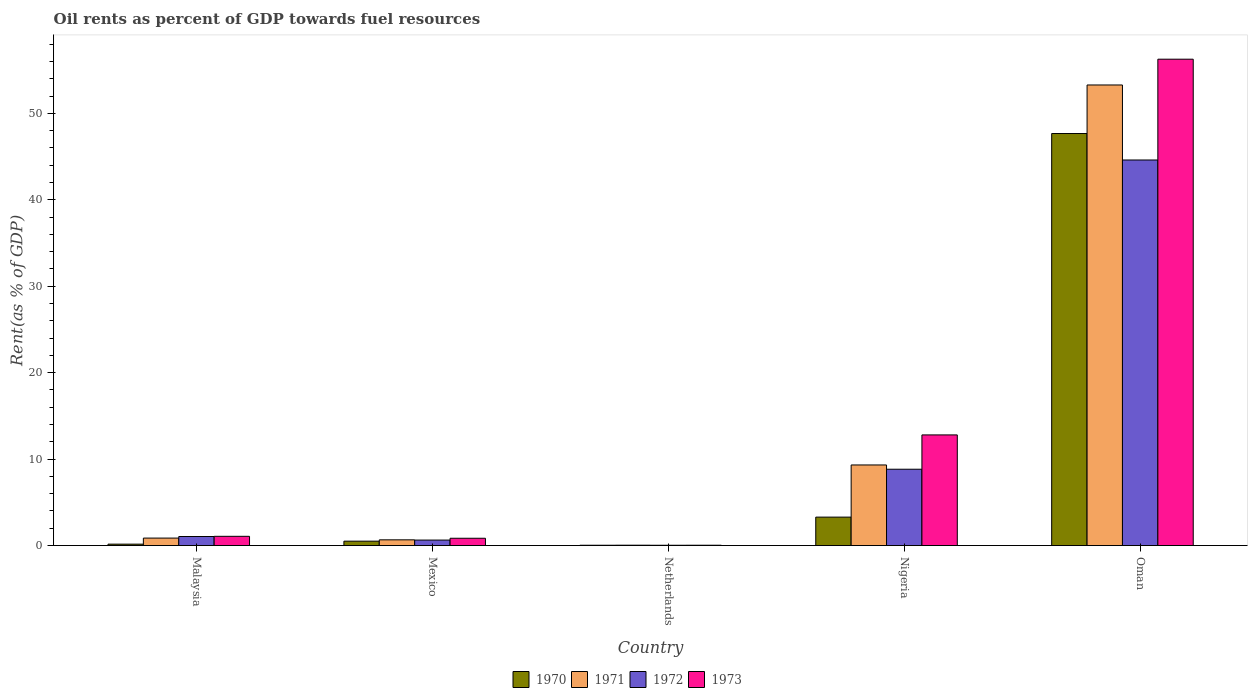Are the number of bars on each tick of the X-axis equal?
Your answer should be very brief. Yes. In how many cases, is the number of bars for a given country not equal to the number of legend labels?
Ensure brevity in your answer.  0. What is the oil rent in 1972 in Oman?
Offer a terse response. 44.6. Across all countries, what is the maximum oil rent in 1972?
Provide a short and direct response. 44.6. Across all countries, what is the minimum oil rent in 1973?
Your answer should be very brief. 0.04. In which country was the oil rent in 1970 maximum?
Offer a terse response. Oman. What is the total oil rent in 1970 in the graph?
Your response must be concise. 51.66. What is the difference between the oil rent in 1970 in Mexico and that in Nigeria?
Offer a terse response. -2.78. What is the difference between the oil rent in 1973 in Nigeria and the oil rent in 1972 in Oman?
Your answer should be compact. -31.8. What is the average oil rent in 1973 per country?
Offer a very short reply. 14.2. What is the difference between the oil rent of/in 1971 and oil rent of/in 1973 in Malaysia?
Provide a short and direct response. -0.2. What is the ratio of the oil rent in 1970 in Mexico to that in Nigeria?
Give a very brief answer. 0.15. Is the difference between the oil rent in 1971 in Mexico and Nigeria greater than the difference between the oil rent in 1973 in Mexico and Nigeria?
Your answer should be compact. Yes. What is the difference between the highest and the second highest oil rent in 1970?
Your answer should be very brief. -2.78. What is the difference between the highest and the lowest oil rent in 1970?
Provide a short and direct response. 47.62. In how many countries, is the oil rent in 1970 greater than the average oil rent in 1970 taken over all countries?
Ensure brevity in your answer.  1. Is it the case that in every country, the sum of the oil rent in 1970 and oil rent in 1972 is greater than the sum of oil rent in 1973 and oil rent in 1971?
Make the answer very short. No. Is it the case that in every country, the sum of the oil rent in 1970 and oil rent in 1972 is greater than the oil rent in 1971?
Make the answer very short. Yes. Are all the bars in the graph horizontal?
Your answer should be compact. No. Are the values on the major ticks of Y-axis written in scientific E-notation?
Make the answer very short. No. Does the graph contain grids?
Your answer should be compact. No. Where does the legend appear in the graph?
Provide a succinct answer. Bottom center. How are the legend labels stacked?
Provide a succinct answer. Horizontal. What is the title of the graph?
Give a very brief answer. Oil rents as percent of GDP towards fuel resources. Does "1966" appear as one of the legend labels in the graph?
Ensure brevity in your answer.  No. What is the label or title of the X-axis?
Give a very brief answer. Country. What is the label or title of the Y-axis?
Provide a succinct answer. Rent(as % of GDP). What is the Rent(as % of GDP) in 1970 in Malaysia?
Give a very brief answer. 0.16. What is the Rent(as % of GDP) in 1971 in Malaysia?
Offer a terse response. 0.86. What is the Rent(as % of GDP) in 1972 in Malaysia?
Ensure brevity in your answer.  1.05. What is the Rent(as % of GDP) in 1973 in Malaysia?
Offer a terse response. 1.07. What is the Rent(as % of GDP) in 1970 in Mexico?
Keep it short and to the point. 0.51. What is the Rent(as % of GDP) of 1971 in Mexico?
Keep it short and to the point. 0.66. What is the Rent(as % of GDP) of 1972 in Mexico?
Offer a terse response. 0.63. What is the Rent(as % of GDP) of 1973 in Mexico?
Keep it short and to the point. 0.84. What is the Rent(as % of GDP) in 1970 in Netherlands?
Offer a very short reply. 0.04. What is the Rent(as % of GDP) in 1971 in Netherlands?
Your answer should be very brief. 0.04. What is the Rent(as % of GDP) in 1972 in Netherlands?
Ensure brevity in your answer.  0.03. What is the Rent(as % of GDP) of 1973 in Netherlands?
Offer a terse response. 0.04. What is the Rent(as % of GDP) in 1970 in Nigeria?
Give a very brief answer. 3.29. What is the Rent(as % of GDP) of 1971 in Nigeria?
Make the answer very short. 9.32. What is the Rent(as % of GDP) of 1972 in Nigeria?
Ensure brevity in your answer.  8.83. What is the Rent(as % of GDP) of 1973 in Nigeria?
Make the answer very short. 12.8. What is the Rent(as % of GDP) of 1970 in Oman?
Give a very brief answer. 47.66. What is the Rent(as % of GDP) in 1971 in Oman?
Ensure brevity in your answer.  53.28. What is the Rent(as % of GDP) in 1972 in Oman?
Ensure brevity in your answer.  44.6. What is the Rent(as % of GDP) of 1973 in Oman?
Your answer should be very brief. 56.26. Across all countries, what is the maximum Rent(as % of GDP) in 1970?
Offer a very short reply. 47.66. Across all countries, what is the maximum Rent(as % of GDP) of 1971?
Your response must be concise. 53.28. Across all countries, what is the maximum Rent(as % of GDP) in 1972?
Make the answer very short. 44.6. Across all countries, what is the maximum Rent(as % of GDP) in 1973?
Ensure brevity in your answer.  56.26. Across all countries, what is the minimum Rent(as % of GDP) of 1970?
Offer a very short reply. 0.04. Across all countries, what is the minimum Rent(as % of GDP) of 1971?
Ensure brevity in your answer.  0.04. Across all countries, what is the minimum Rent(as % of GDP) in 1972?
Your response must be concise. 0.03. Across all countries, what is the minimum Rent(as % of GDP) in 1973?
Make the answer very short. 0.04. What is the total Rent(as % of GDP) of 1970 in the graph?
Make the answer very short. 51.66. What is the total Rent(as % of GDP) in 1971 in the graph?
Ensure brevity in your answer.  64.17. What is the total Rent(as % of GDP) of 1972 in the graph?
Your answer should be compact. 55.15. What is the total Rent(as % of GDP) of 1973 in the graph?
Offer a terse response. 71.01. What is the difference between the Rent(as % of GDP) in 1970 in Malaysia and that in Mexico?
Provide a short and direct response. -0.35. What is the difference between the Rent(as % of GDP) of 1971 in Malaysia and that in Mexico?
Make the answer very short. 0.2. What is the difference between the Rent(as % of GDP) in 1972 in Malaysia and that in Mexico?
Offer a very short reply. 0.41. What is the difference between the Rent(as % of GDP) of 1973 in Malaysia and that in Mexico?
Provide a succinct answer. 0.22. What is the difference between the Rent(as % of GDP) of 1970 in Malaysia and that in Netherlands?
Provide a short and direct response. 0.13. What is the difference between the Rent(as % of GDP) of 1971 in Malaysia and that in Netherlands?
Make the answer very short. 0.82. What is the difference between the Rent(as % of GDP) in 1972 in Malaysia and that in Netherlands?
Make the answer very short. 1.01. What is the difference between the Rent(as % of GDP) in 1973 in Malaysia and that in Netherlands?
Provide a succinct answer. 1.03. What is the difference between the Rent(as % of GDP) of 1970 in Malaysia and that in Nigeria?
Your response must be concise. -3.13. What is the difference between the Rent(as % of GDP) of 1971 in Malaysia and that in Nigeria?
Ensure brevity in your answer.  -8.46. What is the difference between the Rent(as % of GDP) in 1972 in Malaysia and that in Nigeria?
Give a very brief answer. -7.78. What is the difference between the Rent(as % of GDP) in 1973 in Malaysia and that in Nigeria?
Make the answer very short. -11.73. What is the difference between the Rent(as % of GDP) of 1970 in Malaysia and that in Oman?
Give a very brief answer. -47.5. What is the difference between the Rent(as % of GDP) of 1971 in Malaysia and that in Oman?
Your answer should be very brief. -52.41. What is the difference between the Rent(as % of GDP) in 1972 in Malaysia and that in Oman?
Provide a succinct answer. -43.55. What is the difference between the Rent(as % of GDP) in 1973 in Malaysia and that in Oman?
Provide a succinct answer. -55.19. What is the difference between the Rent(as % of GDP) in 1970 in Mexico and that in Netherlands?
Offer a terse response. 0.47. What is the difference between the Rent(as % of GDP) in 1971 in Mexico and that in Netherlands?
Provide a succinct answer. 0.62. What is the difference between the Rent(as % of GDP) of 1973 in Mexico and that in Netherlands?
Offer a very short reply. 0.81. What is the difference between the Rent(as % of GDP) in 1970 in Mexico and that in Nigeria?
Your response must be concise. -2.78. What is the difference between the Rent(as % of GDP) of 1971 in Mexico and that in Nigeria?
Provide a succinct answer. -8.66. What is the difference between the Rent(as % of GDP) of 1972 in Mexico and that in Nigeria?
Ensure brevity in your answer.  -8.19. What is the difference between the Rent(as % of GDP) in 1973 in Mexico and that in Nigeria?
Your answer should be very brief. -11.95. What is the difference between the Rent(as % of GDP) in 1970 in Mexico and that in Oman?
Offer a very short reply. -47.15. What is the difference between the Rent(as % of GDP) of 1971 in Mexico and that in Oman?
Provide a short and direct response. -52.61. What is the difference between the Rent(as % of GDP) in 1972 in Mexico and that in Oman?
Make the answer very short. -43.97. What is the difference between the Rent(as % of GDP) in 1973 in Mexico and that in Oman?
Give a very brief answer. -55.41. What is the difference between the Rent(as % of GDP) of 1970 in Netherlands and that in Nigeria?
Offer a very short reply. -3.25. What is the difference between the Rent(as % of GDP) in 1971 in Netherlands and that in Nigeria?
Give a very brief answer. -9.28. What is the difference between the Rent(as % of GDP) in 1972 in Netherlands and that in Nigeria?
Provide a succinct answer. -8.79. What is the difference between the Rent(as % of GDP) of 1973 in Netherlands and that in Nigeria?
Offer a terse response. -12.76. What is the difference between the Rent(as % of GDP) in 1970 in Netherlands and that in Oman?
Offer a very short reply. -47.62. What is the difference between the Rent(as % of GDP) in 1971 in Netherlands and that in Oman?
Make the answer very short. -53.23. What is the difference between the Rent(as % of GDP) of 1972 in Netherlands and that in Oman?
Make the answer very short. -44.57. What is the difference between the Rent(as % of GDP) in 1973 in Netherlands and that in Oman?
Offer a very short reply. -56.22. What is the difference between the Rent(as % of GDP) in 1970 in Nigeria and that in Oman?
Keep it short and to the point. -44.37. What is the difference between the Rent(as % of GDP) in 1971 in Nigeria and that in Oman?
Give a very brief answer. -43.95. What is the difference between the Rent(as % of GDP) in 1972 in Nigeria and that in Oman?
Your answer should be compact. -35.77. What is the difference between the Rent(as % of GDP) in 1973 in Nigeria and that in Oman?
Make the answer very short. -43.46. What is the difference between the Rent(as % of GDP) in 1970 in Malaysia and the Rent(as % of GDP) in 1971 in Mexico?
Ensure brevity in your answer.  -0.5. What is the difference between the Rent(as % of GDP) in 1970 in Malaysia and the Rent(as % of GDP) in 1972 in Mexico?
Provide a short and direct response. -0.47. What is the difference between the Rent(as % of GDP) in 1970 in Malaysia and the Rent(as % of GDP) in 1973 in Mexico?
Your answer should be compact. -0.68. What is the difference between the Rent(as % of GDP) in 1971 in Malaysia and the Rent(as % of GDP) in 1972 in Mexico?
Provide a short and direct response. 0.23. What is the difference between the Rent(as % of GDP) of 1971 in Malaysia and the Rent(as % of GDP) of 1973 in Mexico?
Provide a short and direct response. 0.02. What is the difference between the Rent(as % of GDP) of 1972 in Malaysia and the Rent(as % of GDP) of 1973 in Mexico?
Provide a succinct answer. 0.2. What is the difference between the Rent(as % of GDP) in 1970 in Malaysia and the Rent(as % of GDP) in 1971 in Netherlands?
Give a very brief answer. 0.12. What is the difference between the Rent(as % of GDP) in 1970 in Malaysia and the Rent(as % of GDP) in 1972 in Netherlands?
Your answer should be very brief. 0.13. What is the difference between the Rent(as % of GDP) in 1970 in Malaysia and the Rent(as % of GDP) in 1973 in Netherlands?
Your answer should be very brief. 0.12. What is the difference between the Rent(as % of GDP) of 1971 in Malaysia and the Rent(as % of GDP) of 1972 in Netherlands?
Give a very brief answer. 0.83. What is the difference between the Rent(as % of GDP) in 1971 in Malaysia and the Rent(as % of GDP) in 1973 in Netherlands?
Provide a succinct answer. 0.82. What is the difference between the Rent(as % of GDP) of 1972 in Malaysia and the Rent(as % of GDP) of 1973 in Netherlands?
Offer a terse response. 1.01. What is the difference between the Rent(as % of GDP) of 1970 in Malaysia and the Rent(as % of GDP) of 1971 in Nigeria?
Your answer should be compact. -9.16. What is the difference between the Rent(as % of GDP) of 1970 in Malaysia and the Rent(as % of GDP) of 1972 in Nigeria?
Offer a very short reply. -8.67. What is the difference between the Rent(as % of GDP) in 1970 in Malaysia and the Rent(as % of GDP) in 1973 in Nigeria?
Give a very brief answer. -12.64. What is the difference between the Rent(as % of GDP) of 1971 in Malaysia and the Rent(as % of GDP) of 1972 in Nigeria?
Your response must be concise. -7.96. What is the difference between the Rent(as % of GDP) of 1971 in Malaysia and the Rent(as % of GDP) of 1973 in Nigeria?
Give a very brief answer. -11.94. What is the difference between the Rent(as % of GDP) of 1972 in Malaysia and the Rent(as % of GDP) of 1973 in Nigeria?
Provide a short and direct response. -11.75. What is the difference between the Rent(as % of GDP) in 1970 in Malaysia and the Rent(as % of GDP) in 1971 in Oman?
Make the answer very short. -53.11. What is the difference between the Rent(as % of GDP) of 1970 in Malaysia and the Rent(as % of GDP) of 1972 in Oman?
Your response must be concise. -44.44. What is the difference between the Rent(as % of GDP) of 1970 in Malaysia and the Rent(as % of GDP) of 1973 in Oman?
Keep it short and to the point. -56.1. What is the difference between the Rent(as % of GDP) of 1971 in Malaysia and the Rent(as % of GDP) of 1972 in Oman?
Keep it short and to the point. -43.74. What is the difference between the Rent(as % of GDP) of 1971 in Malaysia and the Rent(as % of GDP) of 1973 in Oman?
Give a very brief answer. -55.39. What is the difference between the Rent(as % of GDP) in 1972 in Malaysia and the Rent(as % of GDP) in 1973 in Oman?
Keep it short and to the point. -55.21. What is the difference between the Rent(as % of GDP) in 1970 in Mexico and the Rent(as % of GDP) in 1971 in Netherlands?
Provide a succinct answer. 0.47. What is the difference between the Rent(as % of GDP) of 1970 in Mexico and the Rent(as % of GDP) of 1972 in Netherlands?
Provide a succinct answer. 0.47. What is the difference between the Rent(as % of GDP) in 1970 in Mexico and the Rent(as % of GDP) in 1973 in Netherlands?
Keep it short and to the point. 0.47. What is the difference between the Rent(as % of GDP) of 1971 in Mexico and the Rent(as % of GDP) of 1972 in Netherlands?
Make the answer very short. 0.63. What is the difference between the Rent(as % of GDP) in 1971 in Mexico and the Rent(as % of GDP) in 1973 in Netherlands?
Provide a succinct answer. 0.62. What is the difference between the Rent(as % of GDP) in 1972 in Mexico and the Rent(as % of GDP) in 1973 in Netherlands?
Give a very brief answer. 0.6. What is the difference between the Rent(as % of GDP) in 1970 in Mexico and the Rent(as % of GDP) in 1971 in Nigeria?
Your response must be concise. -8.81. What is the difference between the Rent(as % of GDP) in 1970 in Mexico and the Rent(as % of GDP) in 1972 in Nigeria?
Offer a terse response. -8.32. What is the difference between the Rent(as % of GDP) of 1970 in Mexico and the Rent(as % of GDP) of 1973 in Nigeria?
Give a very brief answer. -12.29. What is the difference between the Rent(as % of GDP) of 1971 in Mexico and the Rent(as % of GDP) of 1972 in Nigeria?
Your answer should be very brief. -8.17. What is the difference between the Rent(as % of GDP) in 1971 in Mexico and the Rent(as % of GDP) in 1973 in Nigeria?
Ensure brevity in your answer.  -12.14. What is the difference between the Rent(as % of GDP) of 1972 in Mexico and the Rent(as % of GDP) of 1973 in Nigeria?
Offer a terse response. -12.16. What is the difference between the Rent(as % of GDP) of 1970 in Mexico and the Rent(as % of GDP) of 1971 in Oman?
Ensure brevity in your answer.  -52.77. What is the difference between the Rent(as % of GDP) in 1970 in Mexico and the Rent(as % of GDP) in 1972 in Oman?
Your response must be concise. -44.09. What is the difference between the Rent(as % of GDP) in 1970 in Mexico and the Rent(as % of GDP) in 1973 in Oman?
Your response must be concise. -55.75. What is the difference between the Rent(as % of GDP) in 1971 in Mexico and the Rent(as % of GDP) in 1972 in Oman?
Give a very brief answer. -43.94. What is the difference between the Rent(as % of GDP) in 1971 in Mexico and the Rent(as % of GDP) in 1973 in Oman?
Your answer should be compact. -55.6. What is the difference between the Rent(as % of GDP) of 1972 in Mexico and the Rent(as % of GDP) of 1973 in Oman?
Your answer should be compact. -55.62. What is the difference between the Rent(as % of GDP) of 1970 in Netherlands and the Rent(as % of GDP) of 1971 in Nigeria?
Offer a terse response. -9.29. What is the difference between the Rent(as % of GDP) of 1970 in Netherlands and the Rent(as % of GDP) of 1972 in Nigeria?
Your answer should be very brief. -8.79. What is the difference between the Rent(as % of GDP) in 1970 in Netherlands and the Rent(as % of GDP) in 1973 in Nigeria?
Ensure brevity in your answer.  -12.76. What is the difference between the Rent(as % of GDP) of 1971 in Netherlands and the Rent(as % of GDP) of 1972 in Nigeria?
Provide a short and direct response. -8.79. What is the difference between the Rent(as % of GDP) in 1971 in Netherlands and the Rent(as % of GDP) in 1973 in Nigeria?
Make the answer very short. -12.76. What is the difference between the Rent(as % of GDP) in 1972 in Netherlands and the Rent(as % of GDP) in 1973 in Nigeria?
Your answer should be compact. -12.76. What is the difference between the Rent(as % of GDP) in 1970 in Netherlands and the Rent(as % of GDP) in 1971 in Oman?
Ensure brevity in your answer.  -53.24. What is the difference between the Rent(as % of GDP) of 1970 in Netherlands and the Rent(as % of GDP) of 1972 in Oman?
Offer a very short reply. -44.56. What is the difference between the Rent(as % of GDP) in 1970 in Netherlands and the Rent(as % of GDP) in 1973 in Oman?
Offer a very short reply. -56.22. What is the difference between the Rent(as % of GDP) of 1971 in Netherlands and the Rent(as % of GDP) of 1972 in Oman?
Offer a terse response. -44.56. What is the difference between the Rent(as % of GDP) of 1971 in Netherlands and the Rent(as % of GDP) of 1973 in Oman?
Keep it short and to the point. -56.22. What is the difference between the Rent(as % of GDP) of 1972 in Netherlands and the Rent(as % of GDP) of 1973 in Oman?
Keep it short and to the point. -56.22. What is the difference between the Rent(as % of GDP) of 1970 in Nigeria and the Rent(as % of GDP) of 1971 in Oman?
Your answer should be compact. -49.99. What is the difference between the Rent(as % of GDP) of 1970 in Nigeria and the Rent(as % of GDP) of 1972 in Oman?
Make the answer very short. -41.31. What is the difference between the Rent(as % of GDP) in 1970 in Nigeria and the Rent(as % of GDP) in 1973 in Oman?
Your answer should be compact. -52.97. What is the difference between the Rent(as % of GDP) in 1971 in Nigeria and the Rent(as % of GDP) in 1972 in Oman?
Make the answer very short. -35.28. What is the difference between the Rent(as % of GDP) in 1971 in Nigeria and the Rent(as % of GDP) in 1973 in Oman?
Provide a short and direct response. -46.94. What is the difference between the Rent(as % of GDP) of 1972 in Nigeria and the Rent(as % of GDP) of 1973 in Oman?
Your answer should be very brief. -47.43. What is the average Rent(as % of GDP) of 1970 per country?
Provide a short and direct response. 10.33. What is the average Rent(as % of GDP) in 1971 per country?
Provide a succinct answer. 12.83. What is the average Rent(as % of GDP) in 1972 per country?
Offer a very short reply. 11.03. What is the average Rent(as % of GDP) of 1973 per country?
Ensure brevity in your answer.  14.2. What is the difference between the Rent(as % of GDP) in 1970 and Rent(as % of GDP) in 1971 in Malaysia?
Offer a very short reply. -0.7. What is the difference between the Rent(as % of GDP) of 1970 and Rent(as % of GDP) of 1972 in Malaysia?
Keep it short and to the point. -0.89. What is the difference between the Rent(as % of GDP) of 1970 and Rent(as % of GDP) of 1973 in Malaysia?
Your answer should be very brief. -0.91. What is the difference between the Rent(as % of GDP) of 1971 and Rent(as % of GDP) of 1972 in Malaysia?
Your response must be concise. -0.18. What is the difference between the Rent(as % of GDP) of 1971 and Rent(as % of GDP) of 1973 in Malaysia?
Make the answer very short. -0.2. What is the difference between the Rent(as % of GDP) in 1972 and Rent(as % of GDP) in 1973 in Malaysia?
Give a very brief answer. -0.02. What is the difference between the Rent(as % of GDP) of 1970 and Rent(as % of GDP) of 1971 in Mexico?
Ensure brevity in your answer.  -0.15. What is the difference between the Rent(as % of GDP) of 1970 and Rent(as % of GDP) of 1972 in Mexico?
Give a very brief answer. -0.13. What is the difference between the Rent(as % of GDP) in 1970 and Rent(as % of GDP) in 1973 in Mexico?
Your response must be concise. -0.34. What is the difference between the Rent(as % of GDP) of 1971 and Rent(as % of GDP) of 1972 in Mexico?
Your response must be concise. 0.03. What is the difference between the Rent(as % of GDP) in 1971 and Rent(as % of GDP) in 1973 in Mexico?
Offer a terse response. -0.18. What is the difference between the Rent(as % of GDP) in 1972 and Rent(as % of GDP) in 1973 in Mexico?
Your answer should be compact. -0.21. What is the difference between the Rent(as % of GDP) in 1970 and Rent(as % of GDP) in 1971 in Netherlands?
Provide a succinct answer. -0.01. What is the difference between the Rent(as % of GDP) in 1970 and Rent(as % of GDP) in 1972 in Netherlands?
Your response must be concise. 0. What is the difference between the Rent(as % of GDP) in 1970 and Rent(as % of GDP) in 1973 in Netherlands?
Provide a short and direct response. -0. What is the difference between the Rent(as % of GDP) of 1971 and Rent(as % of GDP) of 1972 in Netherlands?
Give a very brief answer. 0.01. What is the difference between the Rent(as % of GDP) in 1971 and Rent(as % of GDP) in 1973 in Netherlands?
Your answer should be very brief. 0. What is the difference between the Rent(as % of GDP) of 1972 and Rent(as % of GDP) of 1973 in Netherlands?
Your answer should be very brief. -0. What is the difference between the Rent(as % of GDP) of 1970 and Rent(as % of GDP) of 1971 in Nigeria?
Your answer should be compact. -6.03. What is the difference between the Rent(as % of GDP) in 1970 and Rent(as % of GDP) in 1972 in Nigeria?
Your answer should be compact. -5.54. What is the difference between the Rent(as % of GDP) in 1970 and Rent(as % of GDP) in 1973 in Nigeria?
Your answer should be very brief. -9.51. What is the difference between the Rent(as % of GDP) in 1971 and Rent(as % of GDP) in 1972 in Nigeria?
Provide a short and direct response. 0.49. What is the difference between the Rent(as % of GDP) in 1971 and Rent(as % of GDP) in 1973 in Nigeria?
Ensure brevity in your answer.  -3.48. What is the difference between the Rent(as % of GDP) of 1972 and Rent(as % of GDP) of 1973 in Nigeria?
Provide a succinct answer. -3.97. What is the difference between the Rent(as % of GDP) of 1970 and Rent(as % of GDP) of 1971 in Oman?
Keep it short and to the point. -5.61. What is the difference between the Rent(as % of GDP) in 1970 and Rent(as % of GDP) in 1972 in Oman?
Give a very brief answer. 3.06. What is the difference between the Rent(as % of GDP) of 1970 and Rent(as % of GDP) of 1973 in Oman?
Offer a terse response. -8.6. What is the difference between the Rent(as % of GDP) of 1971 and Rent(as % of GDP) of 1972 in Oman?
Make the answer very short. 8.68. What is the difference between the Rent(as % of GDP) in 1971 and Rent(as % of GDP) in 1973 in Oman?
Keep it short and to the point. -2.98. What is the difference between the Rent(as % of GDP) in 1972 and Rent(as % of GDP) in 1973 in Oman?
Offer a terse response. -11.66. What is the ratio of the Rent(as % of GDP) of 1970 in Malaysia to that in Mexico?
Your response must be concise. 0.32. What is the ratio of the Rent(as % of GDP) of 1971 in Malaysia to that in Mexico?
Give a very brief answer. 1.3. What is the ratio of the Rent(as % of GDP) in 1972 in Malaysia to that in Mexico?
Offer a very short reply. 1.65. What is the ratio of the Rent(as % of GDP) in 1973 in Malaysia to that in Mexico?
Provide a short and direct response. 1.27. What is the ratio of the Rent(as % of GDP) in 1970 in Malaysia to that in Netherlands?
Offer a terse response. 4.3. What is the ratio of the Rent(as % of GDP) in 1971 in Malaysia to that in Netherlands?
Give a very brief answer. 20.04. What is the ratio of the Rent(as % of GDP) in 1972 in Malaysia to that in Netherlands?
Provide a succinct answer. 30.19. What is the ratio of the Rent(as % of GDP) of 1973 in Malaysia to that in Netherlands?
Your response must be concise. 27.06. What is the ratio of the Rent(as % of GDP) in 1970 in Malaysia to that in Nigeria?
Your response must be concise. 0.05. What is the ratio of the Rent(as % of GDP) of 1971 in Malaysia to that in Nigeria?
Your answer should be compact. 0.09. What is the ratio of the Rent(as % of GDP) in 1972 in Malaysia to that in Nigeria?
Ensure brevity in your answer.  0.12. What is the ratio of the Rent(as % of GDP) of 1973 in Malaysia to that in Nigeria?
Provide a short and direct response. 0.08. What is the ratio of the Rent(as % of GDP) in 1970 in Malaysia to that in Oman?
Your answer should be very brief. 0. What is the ratio of the Rent(as % of GDP) in 1971 in Malaysia to that in Oman?
Give a very brief answer. 0.02. What is the ratio of the Rent(as % of GDP) of 1972 in Malaysia to that in Oman?
Your answer should be very brief. 0.02. What is the ratio of the Rent(as % of GDP) in 1973 in Malaysia to that in Oman?
Provide a succinct answer. 0.02. What is the ratio of the Rent(as % of GDP) of 1970 in Mexico to that in Netherlands?
Your answer should be very brief. 13.43. What is the ratio of the Rent(as % of GDP) of 1971 in Mexico to that in Netherlands?
Provide a short and direct response. 15.37. What is the ratio of the Rent(as % of GDP) in 1972 in Mexico to that in Netherlands?
Your answer should be compact. 18.28. What is the ratio of the Rent(as % of GDP) of 1973 in Mexico to that in Netherlands?
Provide a succinct answer. 21.38. What is the ratio of the Rent(as % of GDP) of 1970 in Mexico to that in Nigeria?
Provide a succinct answer. 0.15. What is the ratio of the Rent(as % of GDP) in 1971 in Mexico to that in Nigeria?
Your response must be concise. 0.07. What is the ratio of the Rent(as % of GDP) of 1972 in Mexico to that in Nigeria?
Your response must be concise. 0.07. What is the ratio of the Rent(as % of GDP) of 1973 in Mexico to that in Nigeria?
Ensure brevity in your answer.  0.07. What is the ratio of the Rent(as % of GDP) of 1970 in Mexico to that in Oman?
Your answer should be very brief. 0.01. What is the ratio of the Rent(as % of GDP) of 1971 in Mexico to that in Oman?
Offer a very short reply. 0.01. What is the ratio of the Rent(as % of GDP) in 1972 in Mexico to that in Oman?
Offer a very short reply. 0.01. What is the ratio of the Rent(as % of GDP) in 1973 in Mexico to that in Oman?
Give a very brief answer. 0.01. What is the ratio of the Rent(as % of GDP) in 1970 in Netherlands to that in Nigeria?
Offer a terse response. 0.01. What is the ratio of the Rent(as % of GDP) of 1971 in Netherlands to that in Nigeria?
Ensure brevity in your answer.  0. What is the ratio of the Rent(as % of GDP) of 1972 in Netherlands to that in Nigeria?
Ensure brevity in your answer.  0. What is the ratio of the Rent(as % of GDP) of 1973 in Netherlands to that in Nigeria?
Your answer should be compact. 0. What is the ratio of the Rent(as % of GDP) of 1970 in Netherlands to that in Oman?
Offer a terse response. 0. What is the ratio of the Rent(as % of GDP) in 1971 in Netherlands to that in Oman?
Keep it short and to the point. 0. What is the ratio of the Rent(as % of GDP) in 1972 in Netherlands to that in Oman?
Ensure brevity in your answer.  0. What is the ratio of the Rent(as % of GDP) in 1973 in Netherlands to that in Oman?
Your response must be concise. 0. What is the ratio of the Rent(as % of GDP) in 1970 in Nigeria to that in Oman?
Provide a short and direct response. 0.07. What is the ratio of the Rent(as % of GDP) in 1971 in Nigeria to that in Oman?
Make the answer very short. 0.17. What is the ratio of the Rent(as % of GDP) of 1972 in Nigeria to that in Oman?
Your answer should be compact. 0.2. What is the ratio of the Rent(as % of GDP) of 1973 in Nigeria to that in Oman?
Provide a succinct answer. 0.23. What is the difference between the highest and the second highest Rent(as % of GDP) of 1970?
Offer a terse response. 44.37. What is the difference between the highest and the second highest Rent(as % of GDP) in 1971?
Keep it short and to the point. 43.95. What is the difference between the highest and the second highest Rent(as % of GDP) of 1972?
Your response must be concise. 35.77. What is the difference between the highest and the second highest Rent(as % of GDP) of 1973?
Offer a very short reply. 43.46. What is the difference between the highest and the lowest Rent(as % of GDP) in 1970?
Your answer should be very brief. 47.62. What is the difference between the highest and the lowest Rent(as % of GDP) of 1971?
Offer a terse response. 53.23. What is the difference between the highest and the lowest Rent(as % of GDP) in 1972?
Offer a terse response. 44.57. What is the difference between the highest and the lowest Rent(as % of GDP) of 1973?
Your response must be concise. 56.22. 